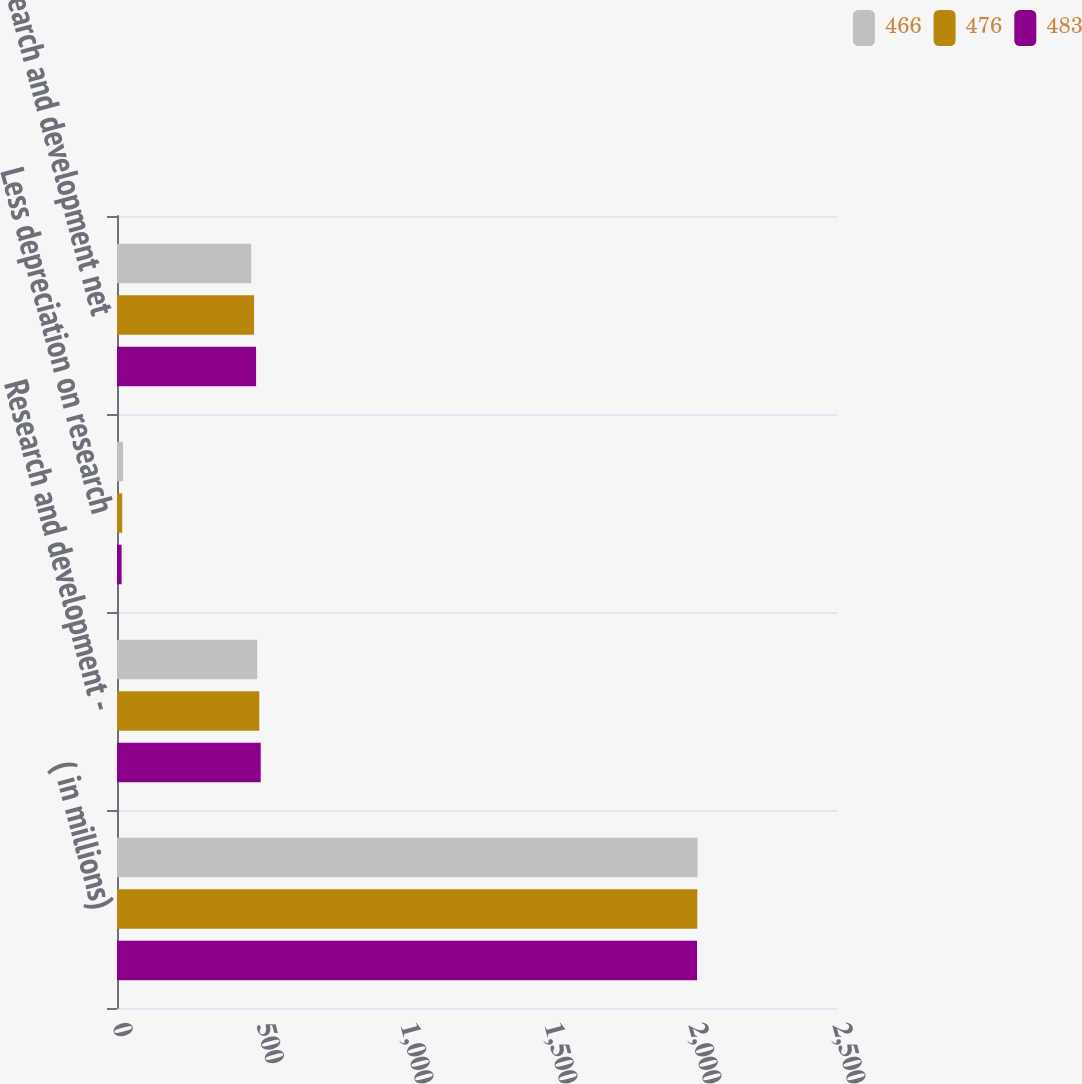Convert chart. <chart><loc_0><loc_0><loc_500><loc_500><stacked_bar_chart><ecel><fcel>( in millions)<fcel>Research and development -<fcel>Less depreciation on research<fcel>Research and development net<nl><fcel>466<fcel>2016<fcel>487<fcel>21<fcel>466<nl><fcel>476<fcel>2015<fcel>494<fcel>18<fcel>476<nl><fcel>483<fcel>2014<fcel>499<fcel>16<fcel>483<nl></chart> 